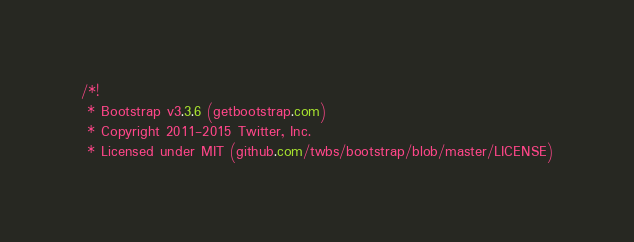Convert code to text. <code><loc_0><loc_0><loc_500><loc_500><_CSS_>/*!
 * Bootstrap v3.3.6 (getbootstrap.com)
 * Copyright 2011-2015 Twitter, Inc.
 * Licensed under MIT (github.com/twbs/bootstrap/blob/master/LICENSE)</code> 